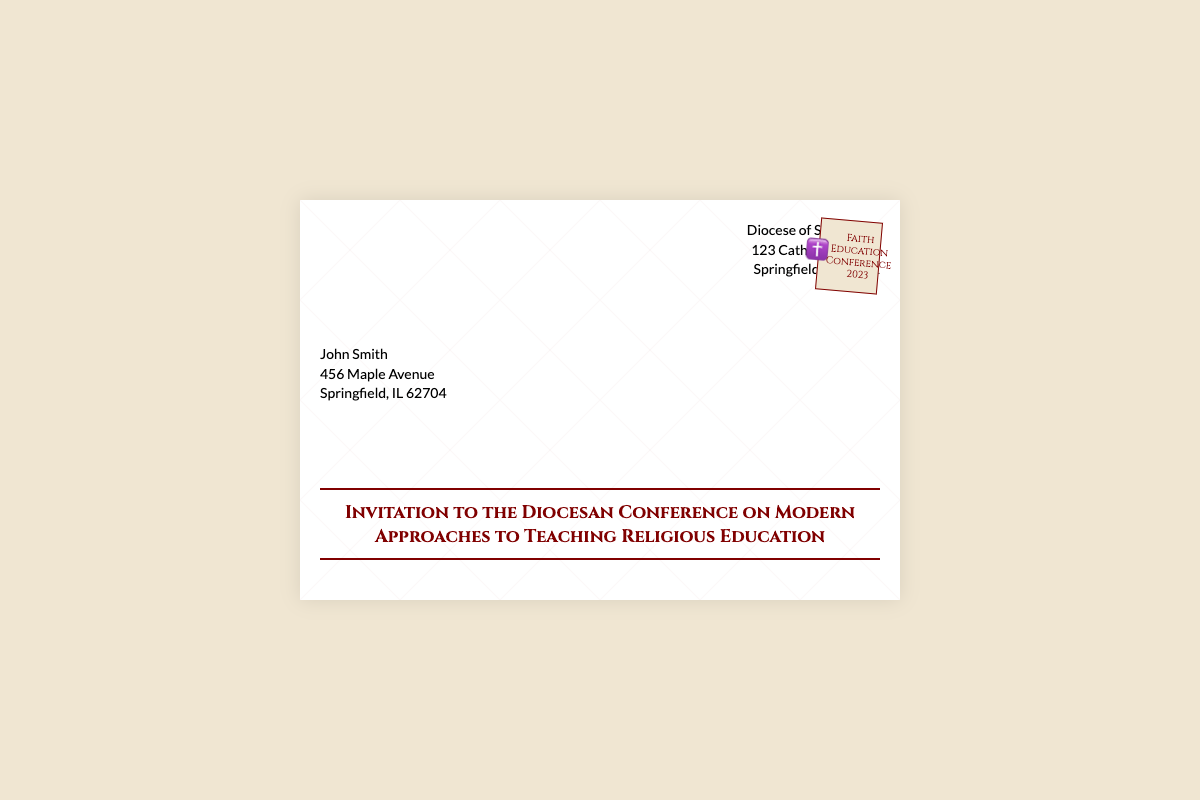What is the name of the conference? The document states that the conference is titled "Diocesan Conference on Modern Approaches to Teaching Religious Education."
Answer: Diocesan Conference on Modern Approaches to Teaching Religious Education Who is the sender of the invitation? The sender information in the document lists "Diocese of Springfield" as the sender.
Answer: Diocese of Springfield What is the address of the recipient? The document provides the recipient's address as "456 Maple Avenue, Springfield, IL 62704."
Answer: 456 Maple Avenue, Springfield, IL 62704 What kind of event is being discussed in the document? The document mentions a conference, specifically focused on teaching religious education.
Answer: Conference What year is the Faith Education Conference? The stamp in the document indicates the year of the conference is 2023.
Answer: 2023 Where is the Diocese of Springfield located? The document lists the address of the Diocese of Springfield as "123 Cathedral Street, Springfield, IL 62701."
Answer: 123 Cathedral Street, Springfield, IL 62701 What is the significance of the ✝️ symbol in the stamp? The symbol indicates a connection to faith, which is central to the religious education theme of the conference.
Answer: Faith How is the subject of the invitation presented? The subject is prominently located in the center of the envelope with a specific font and styling.
Answer: Centered with specific font and styling 